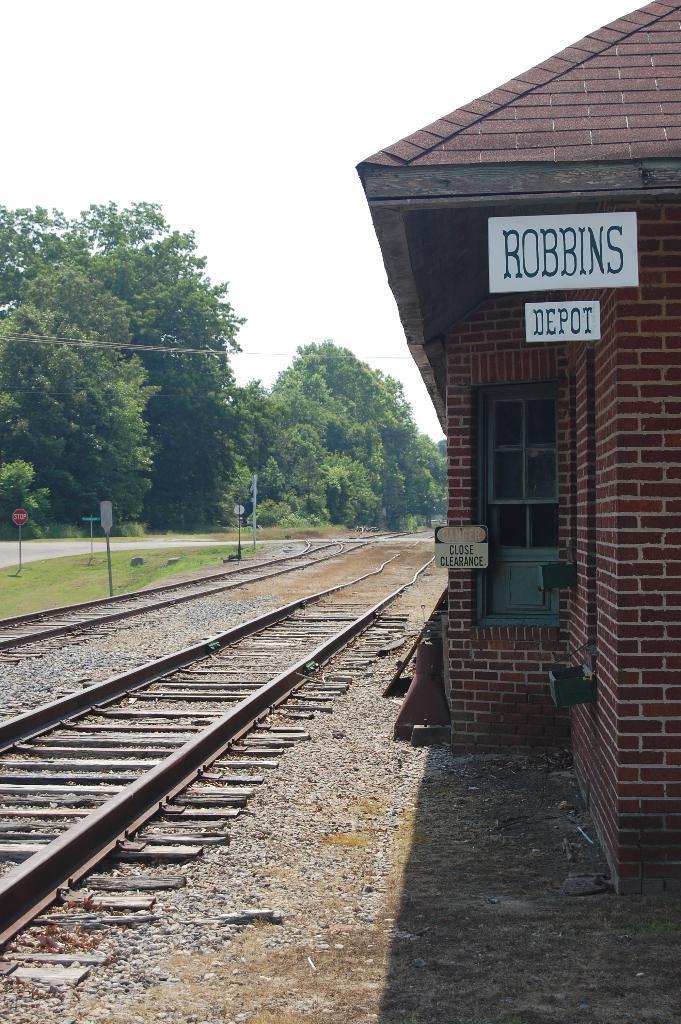Can you describe this image briefly? Here we can see a railway track, house, poles, boards, and trees. This is grass. In the background there is sky. 